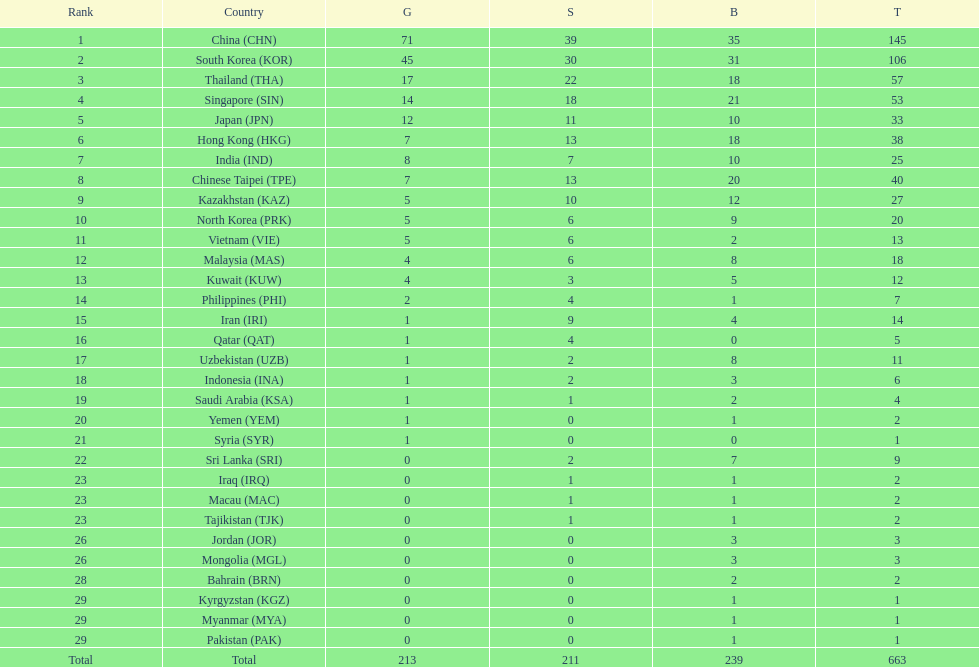What were the number of medals iran earned? 14. 